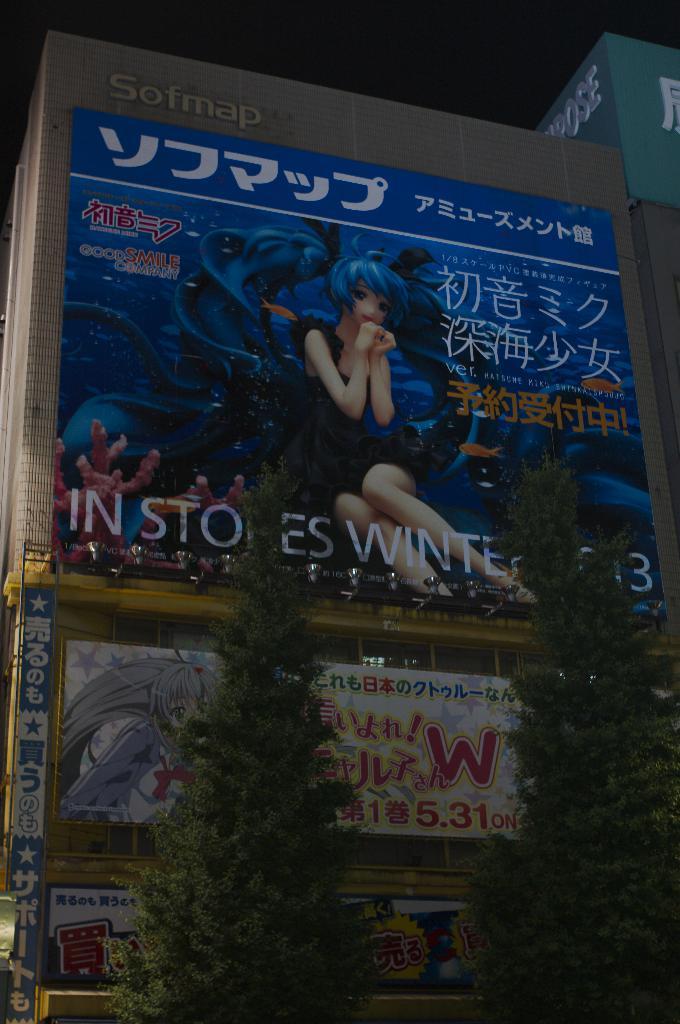Which company is this building part of?
Your answer should be very brief. Sofmap. What is the large red letter?
Ensure brevity in your answer.  W. 